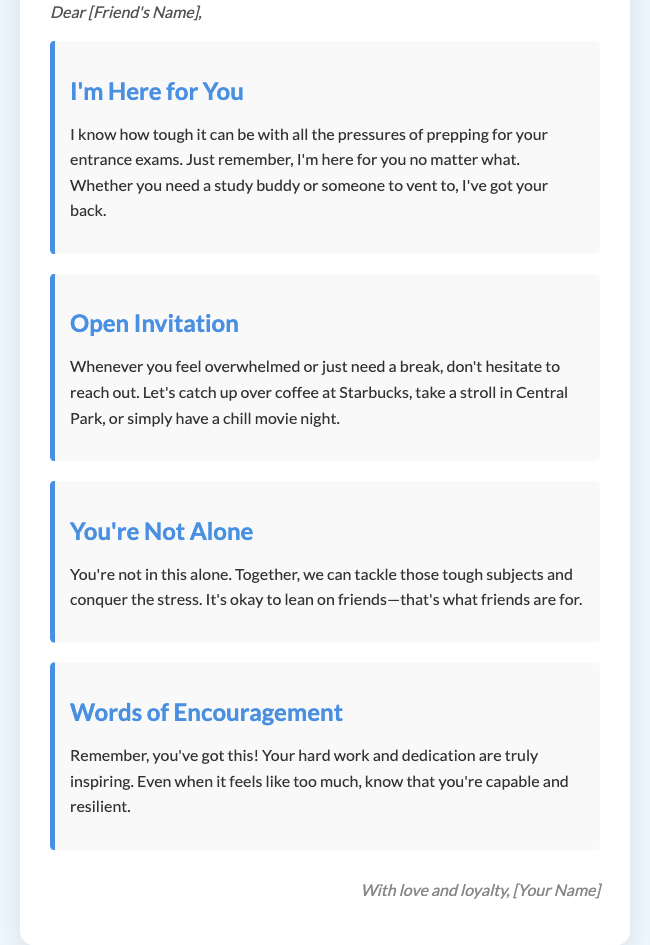What is the title of the card? The title of the card is prominently displayed in a large font at the top of the document.
Answer: A Friend in Need Who is the card addressed to? The card includes a greeting that specifies it is meant for a friend, with a placeholder for their name.
Answer: [Friend's Name] What is one suggested activity to do together? The document lists various activities that can be done together to relieve stress, one of which is specified clearly.
Answer: coffee at Starbucks What color is used for the section titles? The section titles are styled with a specific color that is consistent throughout the document, indicated in the styles section.
Answer: #4a90e2 What message conveys support? The card includes a reassuring phrase to express unwavering support for the recipient, highlighting friendship.
Answer: I've got your back How many sections are in the card? The document includes multiple sections, and a quick count reveals how many distinct messages are conveyed.
Answer: Four What word reflects encouragement in the card? The card contains a phrase that embodies encouragement and positivity for the recipient's efforts.
Answer: inspiring What type of card is this? The overall theme and design, along with the content, indicate a specific type of greeting card tailored for a supportive message.
Answer: greeting card Who is the card signed by? The closing of the document specifies who the greeting is from, emphasizing the personal touch of the card.
Answer: [Your Name] 